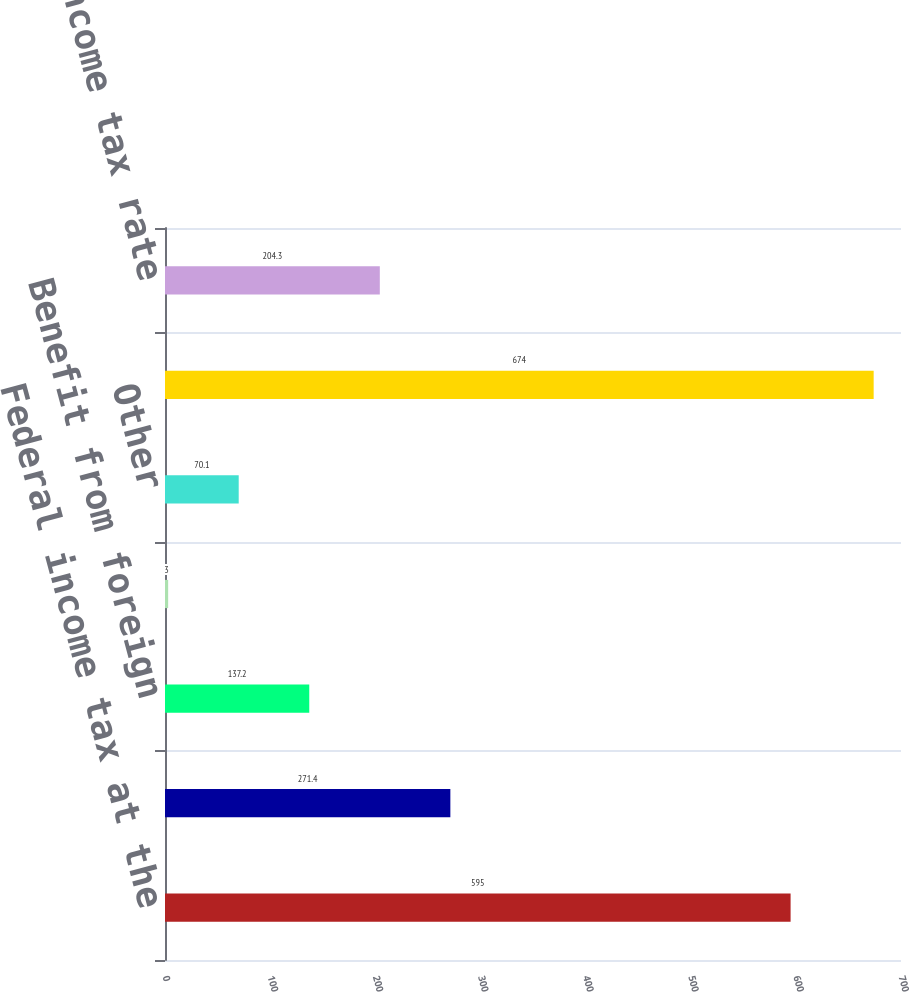Convert chart. <chart><loc_0><loc_0><loc_500><loc_500><bar_chart><fcel>Federal income tax at the<fcel>State income taxes net of<fcel>Benefit from foreign<fcel>Non-taxable interest income<fcel>Other<fcel>Income tax expense<fcel>Effective income tax rate<nl><fcel>595<fcel>271.4<fcel>137.2<fcel>3<fcel>70.1<fcel>674<fcel>204.3<nl></chart> 